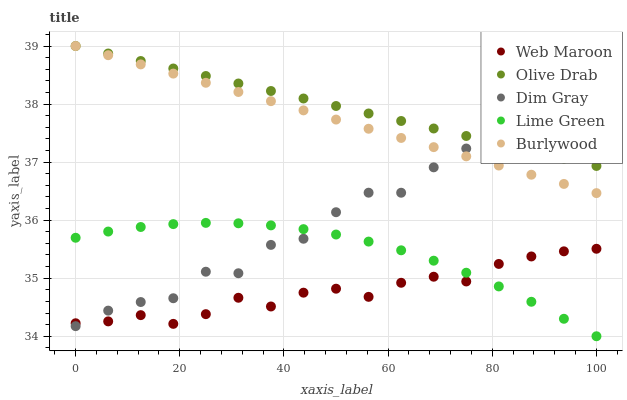Does Web Maroon have the minimum area under the curve?
Answer yes or no. Yes. Does Olive Drab have the maximum area under the curve?
Answer yes or no. Yes. Does Lime Green have the minimum area under the curve?
Answer yes or no. No. Does Lime Green have the maximum area under the curve?
Answer yes or no. No. Is Burlywood the smoothest?
Answer yes or no. Yes. Is Dim Gray the roughest?
Answer yes or no. Yes. Is Lime Green the smoothest?
Answer yes or no. No. Is Lime Green the roughest?
Answer yes or no. No. Does Lime Green have the lowest value?
Answer yes or no. Yes. Does Dim Gray have the lowest value?
Answer yes or no. No. Does Olive Drab have the highest value?
Answer yes or no. Yes. Does Lime Green have the highest value?
Answer yes or no. No. Is Web Maroon less than Burlywood?
Answer yes or no. Yes. Is Burlywood greater than Web Maroon?
Answer yes or no. Yes. Does Burlywood intersect Dim Gray?
Answer yes or no. Yes. Is Burlywood less than Dim Gray?
Answer yes or no. No. Is Burlywood greater than Dim Gray?
Answer yes or no. No. Does Web Maroon intersect Burlywood?
Answer yes or no. No. 